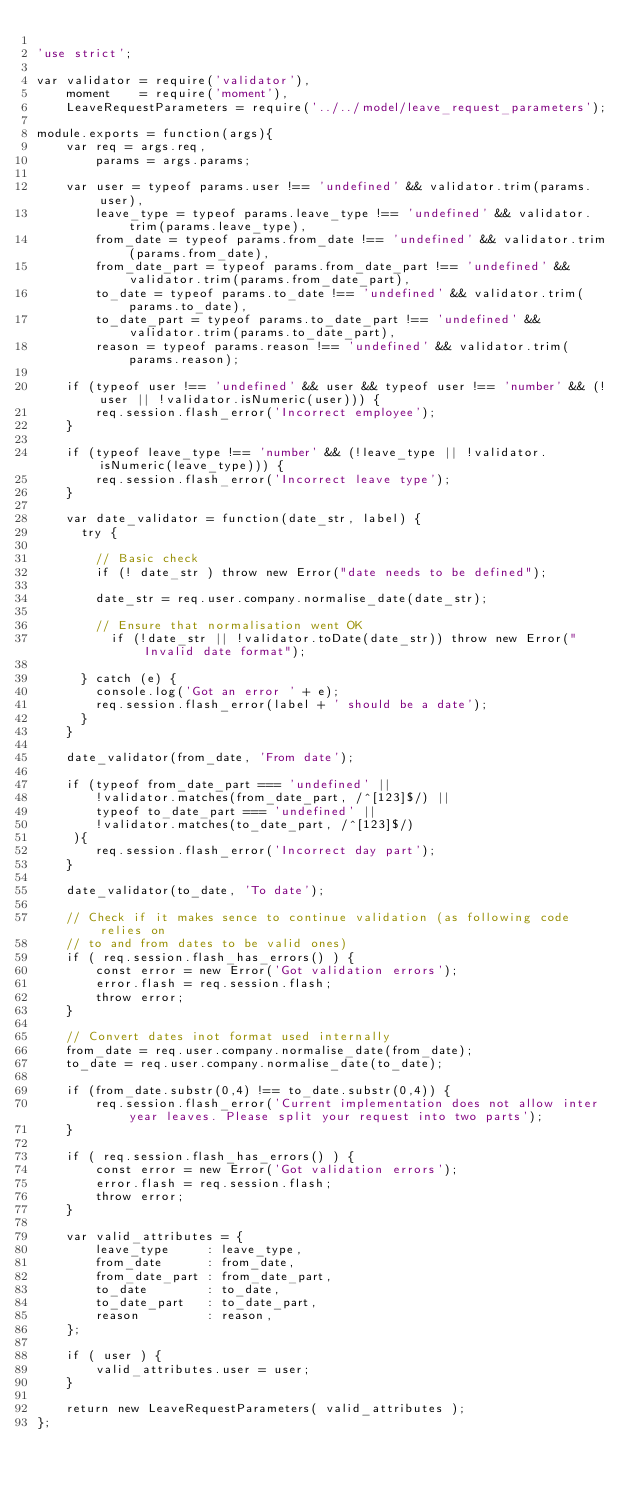<code> <loc_0><loc_0><loc_500><loc_500><_JavaScript_>
'use strict';

var validator = require('validator'),
    moment    = require('moment'),
    LeaveRequestParameters = require('../../model/leave_request_parameters');

module.exports = function(args){
    var req = args.req,
        params = args.params;

    var user = typeof params.user !== 'undefined' && validator.trim(params.user),
        leave_type = typeof params.leave_type !== 'undefined' && validator.trim(params.leave_type),
        from_date = typeof params.from_date !== 'undefined' && validator.trim(params.from_date),
        from_date_part = typeof params.from_date_part !== 'undefined' && validator.trim(params.from_date_part),
        to_date = typeof params.to_date !== 'undefined' && validator.trim(params.to_date),
        to_date_part = typeof params.to_date_part !== 'undefined' && validator.trim(params.to_date_part),
        reason = typeof params.reason !== 'undefined' && validator.trim(params.reason);

    if (typeof user !== 'undefined' && user && typeof user !== 'number' && (!user || !validator.isNumeric(user))) {
        req.session.flash_error('Incorrect employee');
    }

    if (typeof leave_type !== 'number' && (!leave_type || !validator.isNumeric(leave_type))) {
        req.session.flash_error('Incorrect leave type');
    }

    var date_validator = function(date_str, label) {
      try {

        // Basic check
        if (! date_str ) throw new Error("date needs to be defined");

        date_str = req.user.company.normalise_date(date_str);

        // Ensure that normalisation went OK
          if (!date_str || !validator.toDate(date_str)) throw new Error("Invalid date format");

      } catch (e) {
        console.log('Got an error ' + e);
        req.session.flash_error(label + ' should be a date');
      }
    }

    date_validator(from_date, 'From date');

    if (typeof from_date_part === 'undefined' ||
        !validator.matches(from_date_part, /^[123]$/) ||
        typeof to_date_part === 'undefined' ||
        !validator.matches(to_date_part, /^[123]$/)
     ){
        req.session.flash_error('Incorrect day part');
    }

    date_validator(to_date, 'To date');

    // Check if it makes sence to continue validation (as following code relies on
    // to and from dates to be valid ones)
    if ( req.session.flash_has_errors() ) {
        const error = new Error('Got validation errors');
        error.flash = req.session.flash;
        throw error;
    }

    // Convert dates inot format used internally
    from_date = req.user.company.normalise_date(from_date);
    to_date = req.user.company.normalise_date(to_date);

    if (from_date.substr(0,4) !== to_date.substr(0,4)) {
        req.session.flash_error('Current implementation does not allow inter year leaves. Please split your request into two parts');
    }

    if ( req.session.flash_has_errors() ) {
        const error = new Error('Got validation errors');
        error.flash = req.session.flash;
        throw error;
    }

    var valid_attributes = {
        leave_type     : leave_type,
        from_date      : from_date,
        from_date_part : from_date_part,
        to_date        : to_date,
        to_date_part   : to_date_part,
        reason         : reason,
    };

    if ( user ) {
        valid_attributes.user = user;
    }

    return new LeaveRequestParameters( valid_attributes );
};
</code> 